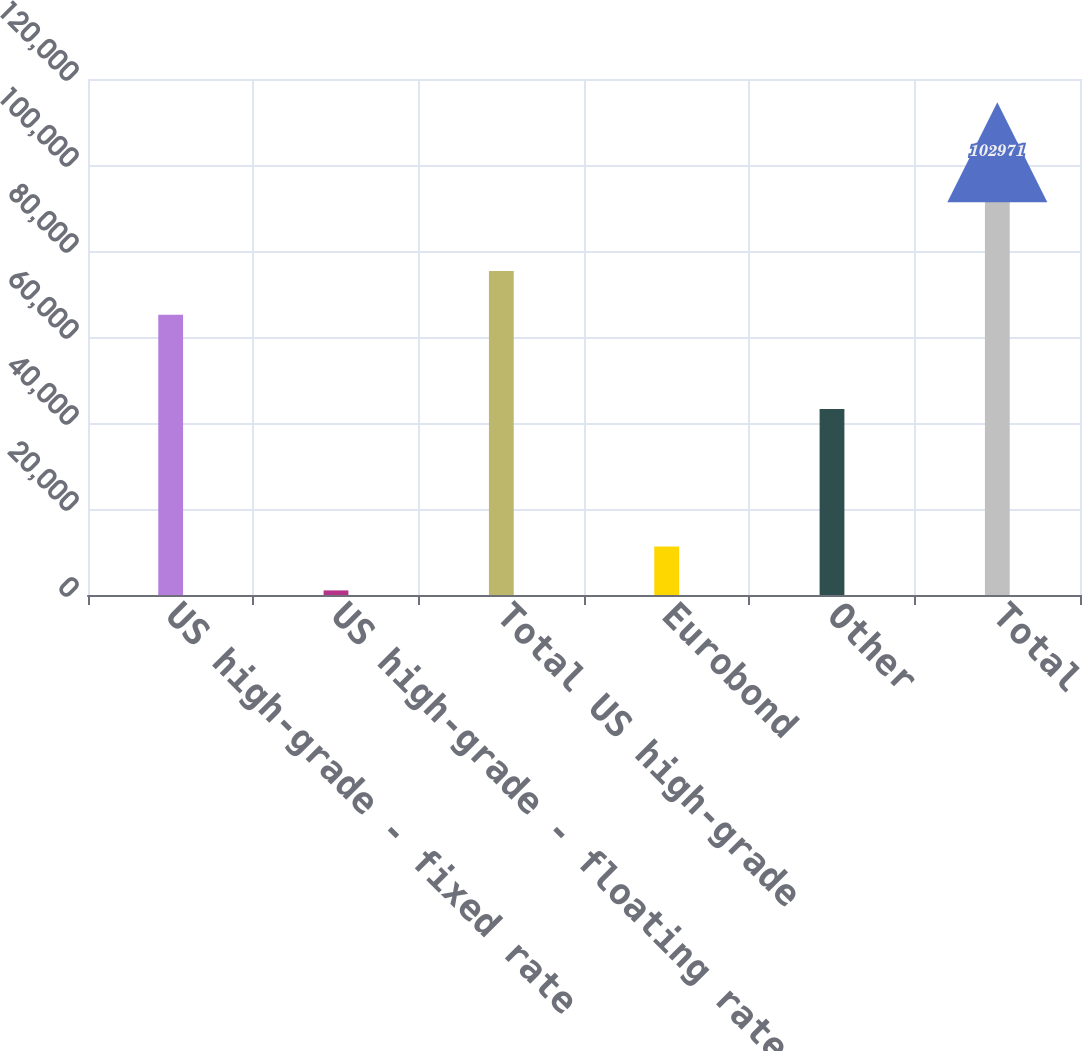Convert chart to OTSL. <chart><loc_0><loc_0><loc_500><loc_500><bar_chart><fcel>US high-grade - fixed rate<fcel>US high-grade - floating rate<fcel>Total US high-grade<fcel>Eurobond<fcel>Other<fcel>Total<nl><fcel>65179<fcel>1069<fcel>75369.2<fcel>11259.2<fcel>43250<fcel>102971<nl></chart> 